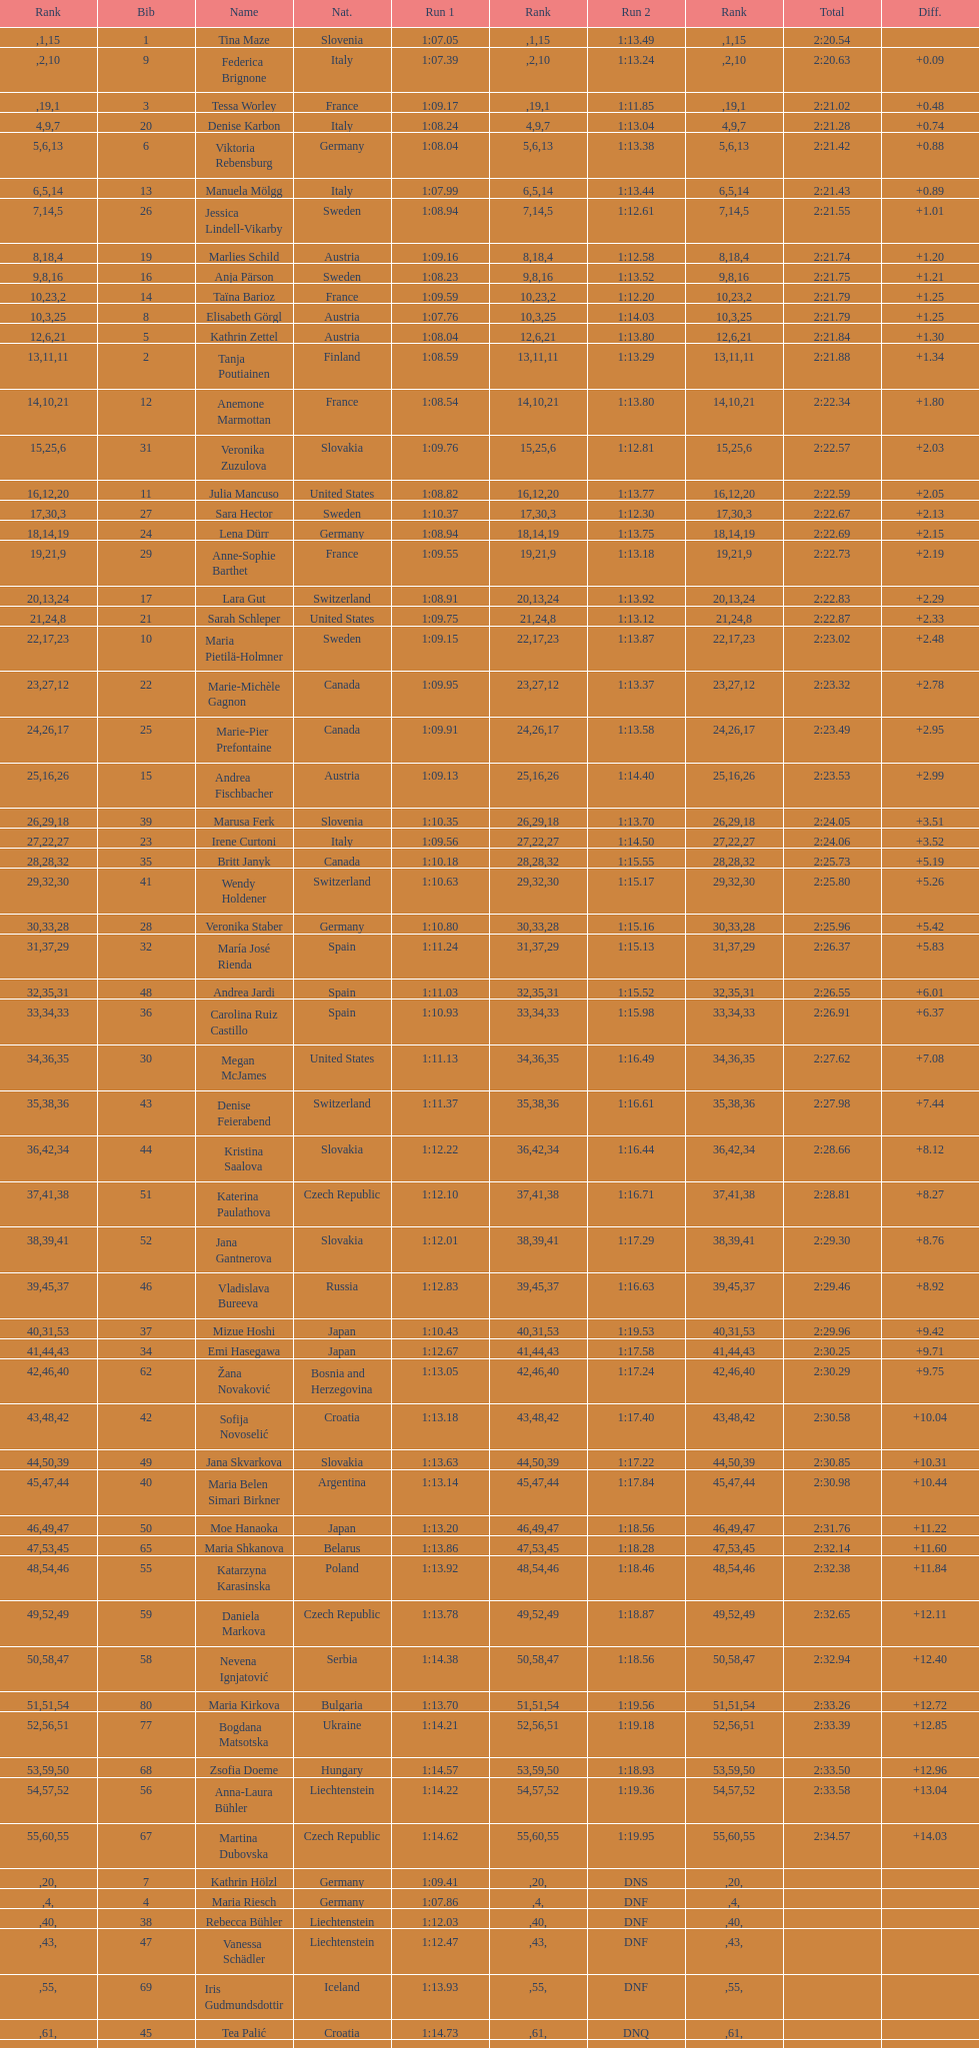Who ranked next after federica brignone? Tessa Worley. 